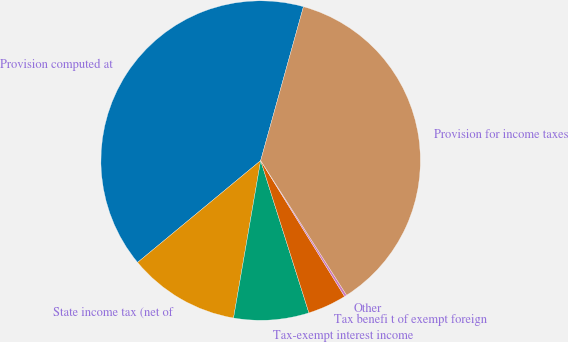Convert chart. <chart><loc_0><loc_0><loc_500><loc_500><pie_chart><fcel>Provision computed at<fcel>State income tax (net of<fcel>Tax-exempt interest income<fcel>Tax benefi t of exempt foreign<fcel>Other<fcel>Provision for income taxes<nl><fcel>40.32%<fcel>11.28%<fcel>7.6%<fcel>3.92%<fcel>0.24%<fcel>36.64%<nl></chart> 